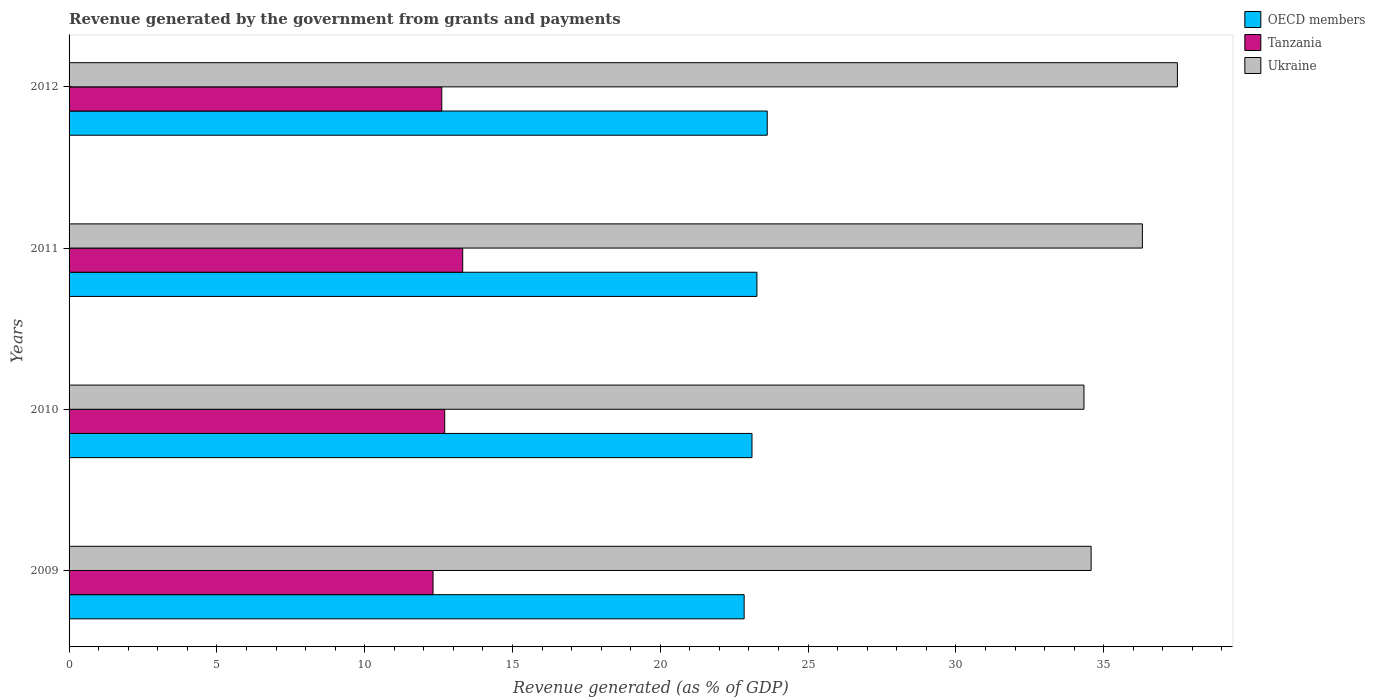How many groups of bars are there?
Your response must be concise. 4. How many bars are there on the 1st tick from the top?
Ensure brevity in your answer.  3. What is the revenue generated by the government in OECD members in 2010?
Give a very brief answer. 23.1. Across all years, what is the maximum revenue generated by the government in OECD members?
Make the answer very short. 23.62. Across all years, what is the minimum revenue generated by the government in Tanzania?
Your response must be concise. 12.31. In which year was the revenue generated by the government in Tanzania maximum?
Ensure brevity in your answer.  2011. In which year was the revenue generated by the government in OECD members minimum?
Your answer should be compact. 2009. What is the total revenue generated by the government in OECD members in the graph?
Make the answer very short. 92.83. What is the difference between the revenue generated by the government in OECD members in 2009 and that in 2010?
Give a very brief answer. -0.27. What is the difference between the revenue generated by the government in Tanzania in 2011 and the revenue generated by the government in OECD members in 2012?
Offer a terse response. -10.3. What is the average revenue generated by the government in Tanzania per year?
Keep it short and to the point. 12.74. In the year 2009, what is the difference between the revenue generated by the government in Tanzania and revenue generated by the government in OECD members?
Give a very brief answer. -10.52. In how many years, is the revenue generated by the government in OECD members greater than 28 %?
Give a very brief answer. 0. What is the ratio of the revenue generated by the government in OECD members in 2010 to that in 2011?
Offer a terse response. 0.99. Is the difference between the revenue generated by the government in Tanzania in 2009 and 2010 greater than the difference between the revenue generated by the government in OECD members in 2009 and 2010?
Offer a terse response. No. What is the difference between the highest and the second highest revenue generated by the government in Tanzania?
Offer a very short reply. 0.61. What is the difference between the highest and the lowest revenue generated by the government in Ukraine?
Give a very brief answer. 3.16. What does the 2nd bar from the top in 2009 represents?
Ensure brevity in your answer.  Tanzania. What does the 3rd bar from the bottom in 2012 represents?
Your response must be concise. Ukraine. How many bars are there?
Your response must be concise. 12. How many years are there in the graph?
Your answer should be very brief. 4. How are the legend labels stacked?
Ensure brevity in your answer.  Vertical. What is the title of the graph?
Keep it short and to the point. Revenue generated by the government from grants and payments. What is the label or title of the X-axis?
Your answer should be compact. Revenue generated (as % of GDP). What is the Revenue generated (as % of GDP) of OECD members in 2009?
Give a very brief answer. 22.84. What is the Revenue generated (as % of GDP) of Tanzania in 2009?
Ensure brevity in your answer.  12.31. What is the Revenue generated (as % of GDP) in Ukraine in 2009?
Your answer should be very brief. 34.58. What is the Revenue generated (as % of GDP) of OECD members in 2010?
Keep it short and to the point. 23.1. What is the Revenue generated (as % of GDP) of Tanzania in 2010?
Ensure brevity in your answer.  12.71. What is the Revenue generated (as % of GDP) of Ukraine in 2010?
Keep it short and to the point. 34.33. What is the Revenue generated (as % of GDP) in OECD members in 2011?
Ensure brevity in your answer.  23.27. What is the Revenue generated (as % of GDP) of Tanzania in 2011?
Provide a succinct answer. 13.32. What is the Revenue generated (as % of GDP) of Ukraine in 2011?
Your answer should be compact. 36.31. What is the Revenue generated (as % of GDP) of OECD members in 2012?
Your answer should be very brief. 23.62. What is the Revenue generated (as % of GDP) of Tanzania in 2012?
Give a very brief answer. 12.61. What is the Revenue generated (as % of GDP) of Ukraine in 2012?
Provide a succinct answer. 37.49. Across all years, what is the maximum Revenue generated (as % of GDP) in OECD members?
Your answer should be compact. 23.62. Across all years, what is the maximum Revenue generated (as % of GDP) of Tanzania?
Your response must be concise. 13.32. Across all years, what is the maximum Revenue generated (as % of GDP) of Ukraine?
Your answer should be compact. 37.49. Across all years, what is the minimum Revenue generated (as % of GDP) in OECD members?
Ensure brevity in your answer.  22.84. Across all years, what is the minimum Revenue generated (as % of GDP) of Tanzania?
Give a very brief answer. 12.31. Across all years, what is the minimum Revenue generated (as % of GDP) in Ukraine?
Your answer should be very brief. 34.33. What is the total Revenue generated (as % of GDP) in OECD members in the graph?
Keep it short and to the point. 92.83. What is the total Revenue generated (as % of GDP) of Tanzania in the graph?
Provide a succinct answer. 50.94. What is the total Revenue generated (as % of GDP) in Ukraine in the graph?
Your answer should be compact. 142.71. What is the difference between the Revenue generated (as % of GDP) in OECD members in 2009 and that in 2010?
Make the answer very short. -0.27. What is the difference between the Revenue generated (as % of GDP) of Tanzania in 2009 and that in 2010?
Offer a terse response. -0.39. What is the difference between the Revenue generated (as % of GDP) of Ukraine in 2009 and that in 2010?
Offer a very short reply. 0.24. What is the difference between the Revenue generated (as % of GDP) of OECD members in 2009 and that in 2011?
Make the answer very short. -0.43. What is the difference between the Revenue generated (as % of GDP) of Tanzania in 2009 and that in 2011?
Ensure brevity in your answer.  -1. What is the difference between the Revenue generated (as % of GDP) of Ukraine in 2009 and that in 2011?
Provide a succinct answer. -1.73. What is the difference between the Revenue generated (as % of GDP) of OECD members in 2009 and that in 2012?
Give a very brief answer. -0.78. What is the difference between the Revenue generated (as % of GDP) in Tanzania in 2009 and that in 2012?
Make the answer very short. -0.3. What is the difference between the Revenue generated (as % of GDP) in Ukraine in 2009 and that in 2012?
Make the answer very short. -2.92. What is the difference between the Revenue generated (as % of GDP) of Tanzania in 2010 and that in 2011?
Offer a terse response. -0.61. What is the difference between the Revenue generated (as % of GDP) in Ukraine in 2010 and that in 2011?
Make the answer very short. -1.98. What is the difference between the Revenue generated (as % of GDP) of OECD members in 2010 and that in 2012?
Give a very brief answer. -0.52. What is the difference between the Revenue generated (as % of GDP) of Tanzania in 2010 and that in 2012?
Offer a terse response. 0.1. What is the difference between the Revenue generated (as % of GDP) in Ukraine in 2010 and that in 2012?
Ensure brevity in your answer.  -3.16. What is the difference between the Revenue generated (as % of GDP) of OECD members in 2011 and that in 2012?
Ensure brevity in your answer.  -0.35. What is the difference between the Revenue generated (as % of GDP) of Tanzania in 2011 and that in 2012?
Keep it short and to the point. 0.71. What is the difference between the Revenue generated (as % of GDP) of Ukraine in 2011 and that in 2012?
Your answer should be compact. -1.18. What is the difference between the Revenue generated (as % of GDP) in OECD members in 2009 and the Revenue generated (as % of GDP) in Tanzania in 2010?
Offer a very short reply. 10.13. What is the difference between the Revenue generated (as % of GDP) in OECD members in 2009 and the Revenue generated (as % of GDP) in Ukraine in 2010?
Keep it short and to the point. -11.5. What is the difference between the Revenue generated (as % of GDP) of Tanzania in 2009 and the Revenue generated (as % of GDP) of Ukraine in 2010?
Give a very brief answer. -22.02. What is the difference between the Revenue generated (as % of GDP) of OECD members in 2009 and the Revenue generated (as % of GDP) of Tanzania in 2011?
Provide a succinct answer. 9.52. What is the difference between the Revenue generated (as % of GDP) in OECD members in 2009 and the Revenue generated (as % of GDP) in Ukraine in 2011?
Your answer should be very brief. -13.47. What is the difference between the Revenue generated (as % of GDP) of Tanzania in 2009 and the Revenue generated (as % of GDP) of Ukraine in 2011?
Your response must be concise. -24. What is the difference between the Revenue generated (as % of GDP) of OECD members in 2009 and the Revenue generated (as % of GDP) of Tanzania in 2012?
Your answer should be very brief. 10.23. What is the difference between the Revenue generated (as % of GDP) of OECD members in 2009 and the Revenue generated (as % of GDP) of Ukraine in 2012?
Keep it short and to the point. -14.66. What is the difference between the Revenue generated (as % of GDP) in Tanzania in 2009 and the Revenue generated (as % of GDP) in Ukraine in 2012?
Offer a terse response. -25.18. What is the difference between the Revenue generated (as % of GDP) in OECD members in 2010 and the Revenue generated (as % of GDP) in Tanzania in 2011?
Your response must be concise. 9.79. What is the difference between the Revenue generated (as % of GDP) of OECD members in 2010 and the Revenue generated (as % of GDP) of Ukraine in 2011?
Your response must be concise. -13.21. What is the difference between the Revenue generated (as % of GDP) in Tanzania in 2010 and the Revenue generated (as % of GDP) in Ukraine in 2011?
Ensure brevity in your answer.  -23.6. What is the difference between the Revenue generated (as % of GDP) of OECD members in 2010 and the Revenue generated (as % of GDP) of Tanzania in 2012?
Give a very brief answer. 10.49. What is the difference between the Revenue generated (as % of GDP) in OECD members in 2010 and the Revenue generated (as % of GDP) in Ukraine in 2012?
Ensure brevity in your answer.  -14.39. What is the difference between the Revenue generated (as % of GDP) in Tanzania in 2010 and the Revenue generated (as % of GDP) in Ukraine in 2012?
Keep it short and to the point. -24.79. What is the difference between the Revenue generated (as % of GDP) in OECD members in 2011 and the Revenue generated (as % of GDP) in Tanzania in 2012?
Keep it short and to the point. 10.66. What is the difference between the Revenue generated (as % of GDP) in OECD members in 2011 and the Revenue generated (as % of GDP) in Ukraine in 2012?
Your answer should be compact. -14.22. What is the difference between the Revenue generated (as % of GDP) of Tanzania in 2011 and the Revenue generated (as % of GDP) of Ukraine in 2012?
Your response must be concise. -24.18. What is the average Revenue generated (as % of GDP) of OECD members per year?
Provide a succinct answer. 23.21. What is the average Revenue generated (as % of GDP) of Tanzania per year?
Provide a short and direct response. 12.74. What is the average Revenue generated (as % of GDP) of Ukraine per year?
Provide a short and direct response. 35.68. In the year 2009, what is the difference between the Revenue generated (as % of GDP) of OECD members and Revenue generated (as % of GDP) of Tanzania?
Ensure brevity in your answer.  10.52. In the year 2009, what is the difference between the Revenue generated (as % of GDP) of OECD members and Revenue generated (as % of GDP) of Ukraine?
Your answer should be compact. -11.74. In the year 2009, what is the difference between the Revenue generated (as % of GDP) of Tanzania and Revenue generated (as % of GDP) of Ukraine?
Offer a terse response. -22.26. In the year 2010, what is the difference between the Revenue generated (as % of GDP) in OECD members and Revenue generated (as % of GDP) in Tanzania?
Give a very brief answer. 10.39. In the year 2010, what is the difference between the Revenue generated (as % of GDP) in OECD members and Revenue generated (as % of GDP) in Ukraine?
Keep it short and to the point. -11.23. In the year 2010, what is the difference between the Revenue generated (as % of GDP) in Tanzania and Revenue generated (as % of GDP) in Ukraine?
Provide a short and direct response. -21.63. In the year 2011, what is the difference between the Revenue generated (as % of GDP) of OECD members and Revenue generated (as % of GDP) of Tanzania?
Your answer should be very brief. 9.95. In the year 2011, what is the difference between the Revenue generated (as % of GDP) in OECD members and Revenue generated (as % of GDP) in Ukraine?
Give a very brief answer. -13.04. In the year 2011, what is the difference between the Revenue generated (as % of GDP) in Tanzania and Revenue generated (as % of GDP) in Ukraine?
Provide a succinct answer. -22.99. In the year 2012, what is the difference between the Revenue generated (as % of GDP) in OECD members and Revenue generated (as % of GDP) in Tanzania?
Provide a short and direct response. 11.01. In the year 2012, what is the difference between the Revenue generated (as % of GDP) of OECD members and Revenue generated (as % of GDP) of Ukraine?
Provide a short and direct response. -13.88. In the year 2012, what is the difference between the Revenue generated (as % of GDP) of Tanzania and Revenue generated (as % of GDP) of Ukraine?
Give a very brief answer. -24.89. What is the ratio of the Revenue generated (as % of GDP) of Tanzania in 2009 to that in 2010?
Offer a very short reply. 0.97. What is the ratio of the Revenue generated (as % of GDP) in Ukraine in 2009 to that in 2010?
Make the answer very short. 1.01. What is the ratio of the Revenue generated (as % of GDP) in OECD members in 2009 to that in 2011?
Ensure brevity in your answer.  0.98. What is the ratio of the Revenue generated (as % of GDP) of Tanzania in 2009 to that in 2011?
Offer a very short reply. 0.92. What is the ratio of the Revenue generated (as % of GDP) of Ukraine in 2009 to that in 2011?
Your answer should be compact. 0.95. What is the ratio of the Revenue generated (as % of GDP) in OECD members in 2009 to that in 2012?
Your response must be concise. 0.97. What is the ratio of the Revenue generated (as % of GDP) in Tanzania in 2009 to that in 2012?
Provide a short and direct response. 0.98. What is the ratio of the Revenue generated (as % of GDP) of Ukraine in 2009 to that in 2012?
Your answer should be compact. 0.92. What is the ratio of the Revenue generated (as % of GDP) of Tanzania in 2010 to that in 2011?
Provide a short and direct response. 0.95. What is the ratio of the Revenue generated (as % of GDP) in Ukraine in 2010 to that in 2011?
Your answer should be compact. 0.95. What is the ratio of the Revenue generated (as % of GDP) of OECD members in 2010 to that in 2012?
Your answer should be compact. 0.98. What is the ratio of the Revenue generated (as % of GDP) of Tanzania in 2010 to that in 2012?
Your answer should be very brief. 1.01. What is the ratio of the Revenue generated (as % of GDP) of Ukraine in 2010 to that in 2012?
Your answer should be very brief. 0.92. What is the ratio of the Revenue generated (as % of GDP) in OECD members in 2011 to that in 2012?
Offer a very short reply. 0.99. What is the ratio of the Revenue generated (as % of GDP) of Tanzania in 2011 to that in 2012?
Offer a terse response. 1.06. What is the ratio of the Revenue generated (as % of GDP) of Ukraine in 2011 to that in 2012?
Provide a short and direct response. 0.97. What is the difference between the highest and the second highest Revenue generated (as % of GDP) of OECD members?
Your response must be concise. 0.35. What is the difference between the highest and the second highest Revenue generated (as % of GDP) of Tanzania?
Your answer should be very brief. 0.61. What is the difference between the highest and the second highest Revenue generated (as % of GDP) in Ukraine?
Make the answer very short. 1.18. What is the difference between the highest and the lowest Revenue generated (as % of GDP) of OECD members?
Ensure brevity in your answer.  0.78. What is the difference between the highest and the lowest Revenue generated (as % of GDP) in Ukraine?
Give a very brief answer. 3.16. 